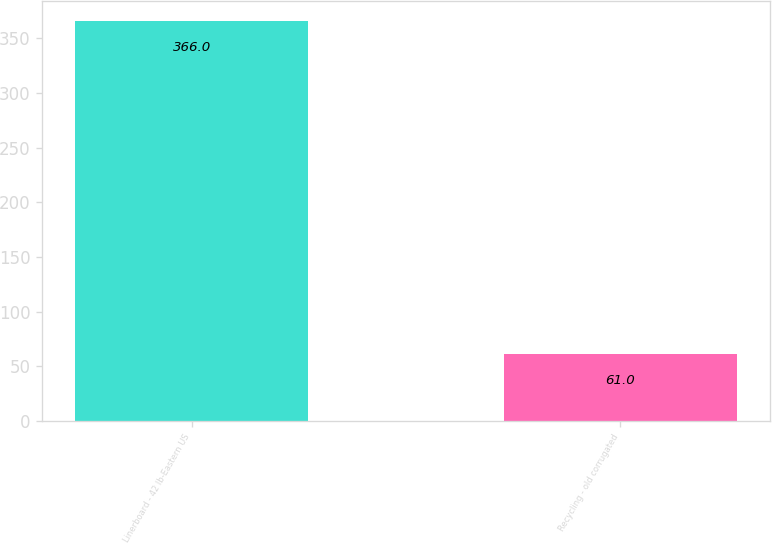Convert chart. <chart><loc_0><loc_0><loc_500><loc_500><bar_chart><fcel>Linerboard - 42 lb-Eastern US<fcel>Recycling - old corrugated<nl><fcel>366<fcel>61<nl></chart> 